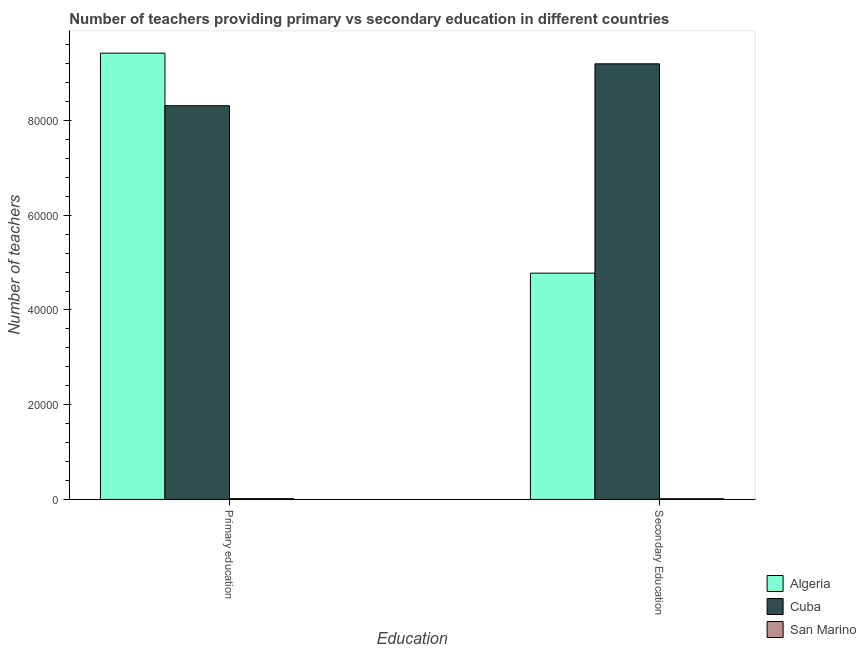How many different coloured bars are there?
Keep it short and to the point. 3. How many groups of bars are there?
Your answer should be compact. 2. Are the number of bars on each tick of the X-axis equal?
Keep it short and to the point. Yes. What is the label of the 1st group of bars from the left?
Make the answer very short. Primary education. What is the number of secondary teachers in Cuba?
Keep it short and to the point. 9.20e+04. Across all countries, what is the maximum number of primary teachers?
Your answer should be very brief. 9.42e+04. Across all countries, what is the minimum number of primary teachers?
Offer a very short reply. 160. In which country was the number of secondary teachers maximum?
Your response must be concise. Cuba. In which country was the number of primary teachers minimum?
Offer a very short reply. San Marino. What is the total number of secondary teachers in the graph?
Offer a terse response. 1.40e+05. What is the difference between the number of primary teachers in Algeria and that in San Marino?
Offer a terse response. 9.41e+04. What is the difference between the number of secondary teachers in Algeria and the number of primary teachers in San Marino?
Your answer should be very brief. 4.76e+04. What is the average number of primary teachers per country?
Offer a terse response. 5.92e+04. What is the difference between the number of secondary teachers and number of primary teachers in Cuba?
Provide a short and direct response. 8847. In how many countries, is the number of primary teachers greater than 76000 ?
Your answer should be very brief. 2. What is the ratio of the number of primary teachers in Cuba to that in Algeria?
Make the answer very short. 0.88. Is the number of primary teachers in Algeria less than that in Cuba?
Make the answer very short. No. What does the 1st bar from the left in Secondary Education represents?
Give a very brief answer. Algeria. What does the 1st bar from the right in Primary education represents?
Ensure brevity in your answer.  San Marino. How many countries are there in the graph?
Your answer should be very brief. 3. What is the difference between two consecutive major ticks on the Y-axis?
Make the answer very short. 2.00e+04. Are the values on the major ticks of Y-axis written in scientific E-notation?
Your answer should be very brief. No. Does the graph contain any zero values?
Your answer should be very brief. No. Does the graph contain grids?
Make the answer very short. No. What is the title of the graph?
Give a very brief answer. Number of teachers providing primary vs secondary education in different countries. What is the label or title of the X-axis?
Give a very brief answer. Education. What is the label or title of the Y-axis?
Offer a very short reply. Number of teachers. What is the Number of teachers in Algeria in Primary education?
Give a very brief answer. 9.42e+04. What is the Number of teachers in Cuba in Primary education?
Offer a very short reply. 8.31e+04. What is the Number of teachers in San Marino in Primary education?
Keep it short and to the point. 160. What is the Number of teachers in Algeria in Secondary Education?
Ensure brevity in your answer.  4.78e+04. What is the Number of teachers of Cuba in Secondary Education?
Give a very brief answer. 9.20e+04. What is the Number of teachers of San Marino in Secondary Education?
Ensure brevity in your answer.  147. Across all Education, what is the maximum Number of teachers of Algeria?
Offer a very short reply. 9.42e+04. Across all Education, what is the maximum Number of teachers in Cuba?
Offer a terse response. 9.20e+04. Across all Education, what is the maximum Number of teachers in San Marino?
Ensure brevity in your answer.  160. Across all Education, what is the minimum Number of teachers of Algeria?
Offer a very short reply. 4.78e+04. Across all Education, what is the minimum Number of teachers of Cuba?
Your response must be concise. 8.31e+04. Across all Education, what is the minimum Number of teachers of San Marino?
Provide a short and direct response. 147. What is the total Number of teachers in Algeria in the graph?
Provide a succinct answer. 1.42e+05. What is the total Number of teachers in Cuba in the graph?
Keep it short and to the point. 1.75e+05. What is the total Number of teachers of San Marino in the graph?
Provide a short and direct response. 307. What is the difference between the Number of teachers of Algeria in Primary education and that in Secondary Education?
Offer a very short reply. 4.64e+04. What is the difference between the Number of teachers of Cuba in Primary education and that in Secondary Education?
Give a very brief answer. -8847. What is the difference between the Number of teachers of San Marino in Primary education and that in Secondary Education?
Provide a succinct answer. 13. What is the difference between the Number of teachers in Algeria in Primary education and the Number of teachers in Cuba in Secondary Education?
Provide a succinct answer. 2256. What is the difference between the Number of teachers of Algeria in Primary education and the Number of teachers of San Marino in Secondary Education?
Provide a succinct answer. 9.41e+04. What is the difference between the Number of teachers of Cuba in Primary education and the Number of teachers of San Marino in Secondary Education?
Your answer should be very brief. 8.30e+04. What is the average Number of teachers of Algeria per Education?
Ensure brevity in your answer.  7.10e+04. What is the average Number of teachers in Cuba per Education?
Provide a short and direct response. 8.75e+04. What is the average Number of teachers of San Marino per Education?
Ensure brevity in your answer.  153.5. What is the difference between the Number of teachers in Algeria and Number of teachers in Cuba in Primary education?
Provide a short and direct response. 1.11e+04. What is the difference between the Number of teachers in Algeria and Number of teachers in San Marino in Primary education?
Provide a short and direct response. 9.41e+04. What is the difference between the Number of teachers in Cuba and Number of teachers in San Marino in Primary education?
Make the answer very short. 8.30e+04. What is the difference between the Number of teachers in Algeria and Number of teachers in Cuba in Secondary Education?
Keep it short and to the point. -4.42e+04. What is the difference between the Number of teachers of Algeria and Number of teachers of San Marino in Secondary Education?
Provide a succinct answer. 4.76e+04. What is the difference between the Number of teachers of Cuba and Number of teachers of San Marino in Secondary Education?
Your answer should be very brief. 9.18e+04. What is the ratio of the Number of teachers of Algeria in Primary education to that in Secondary Education?
Provide a succinct answer. 1.97. What is the ratio of the Number of teachers in Cuba in Primary education to that in Secondary Education?
Keep it short and to the point. 0.9. What is the ratio of the Number of teachers of San Marino in Primary education to that in Secondary Education?
Give a very brief answer. 1.09. What is the difference between the highest and the second highest Number of teachers in Algeria?
Offer a terse response. 4.64e+04. What is the difference between the highest and the second highest Number of teachers in Cuba?
Keep it short and to the point. 8847. What is the difference between the highest and the lowest Number of teachers in Algeria?
Ensure brevity in your answer.  4.64e+04. What is the difference between the highest and the lowest Number of teachers in Cuba?
Make the answer very short. 8847. What is the difference between the highest and the lowest Number of teachers of San Marino?
Keep it short and to the point. 13. 